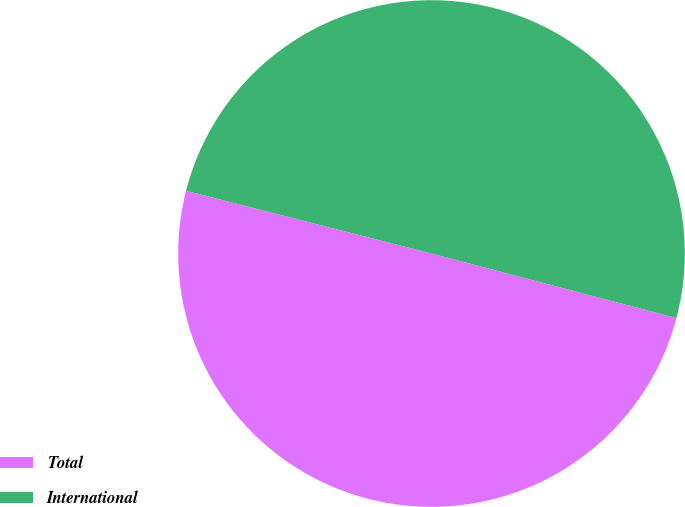Convert chart to OTSL. <chart><loc_0><loc_0><loc_500><loc_500><pie_chart><fcel>Total<fcel>International<nl><fcel>49.88%<fcel>50.12%<nl></chart> 